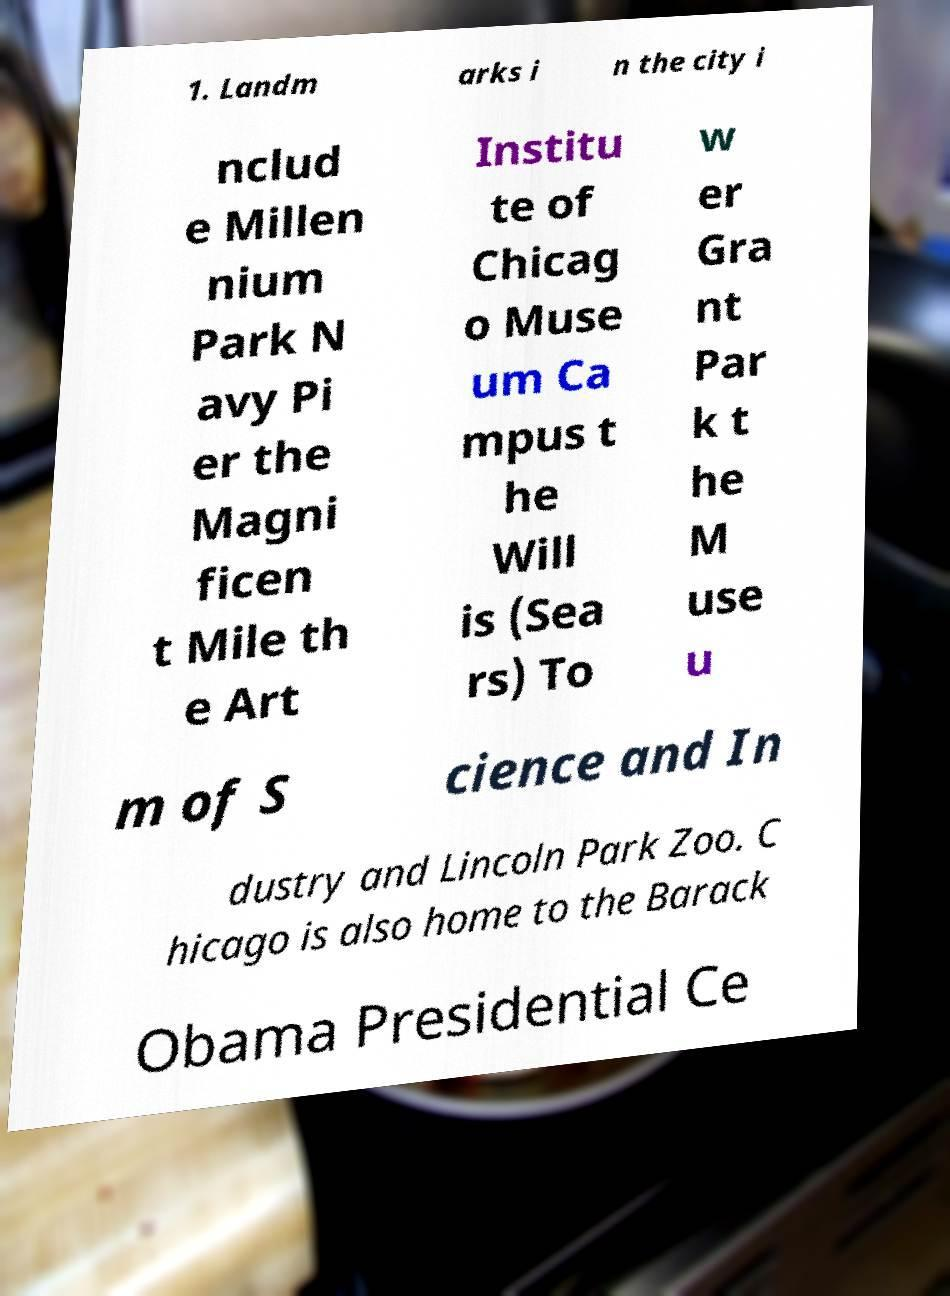Could you assist in decoding the text presented in this image and type it out clearly? 1. Landm arks i n the city i nclud e Millen nium Park N avy Pi er the Magni ficen t Mile th e Art Institu te of Chicag o Muse um Ca mpus t he Will is (Sea rs) To w er Gra nt Par k t he M use u m of S cience and In dustry and Lincoln Park Zoo. C hicago is also home to the Barack Obama Presidential Ce 